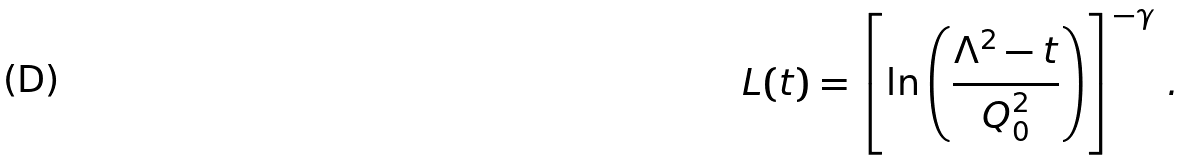Convert formula to latex. <formula><loc_0><loc_0><loc_500><loc_500>L ( t ) = \left [ \ln \left ( \frac { \Lambda ^ { 2 } - t } { Q _ { 0 } ^ { 2 } } \right ) \right ] ^ { - \gamma } \, .</formula> 